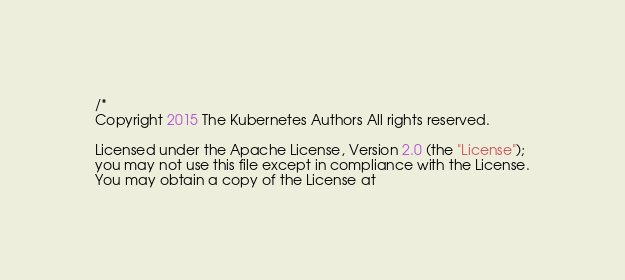Convert code to text. <code><loc_0><loc_0><loc_500><loc_500><_Go_>/*
Copyright 2015 The Kubernetes Authors All rights reserved.

Licensed under the Apache License, Version 2.0 (the "License");
you may not use this file except in compliance with the License.
You may obtain a copy of the License at
</code> 